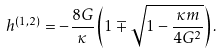<formula> <loc_0><loc_0><loc_500><loc_500>h ^ { ( 1 , 2 ) } = - \frac { 8 G } { \kappa } \left ( 1 \mp \sqrt { 1 - \frac { \kappa m } { 4 G ^ { 2 } } } \right ) .</formula> 